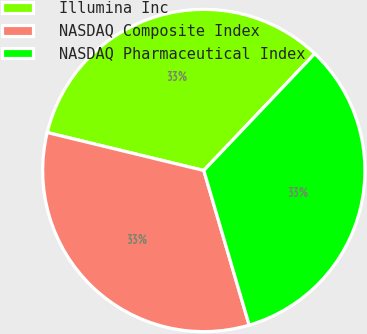Convert chart to OTSL. <chart><loc_0><loc_0><loc_500><loc_500><pie_chart><fcel>Illumina Inc<fcel>NASDAQ Composite Index<fcel>NASDAQ Pharmaceutical Index<nl><fcel>33.3%<fcel>33.33%<fcel>33.37%<nl></chart> 